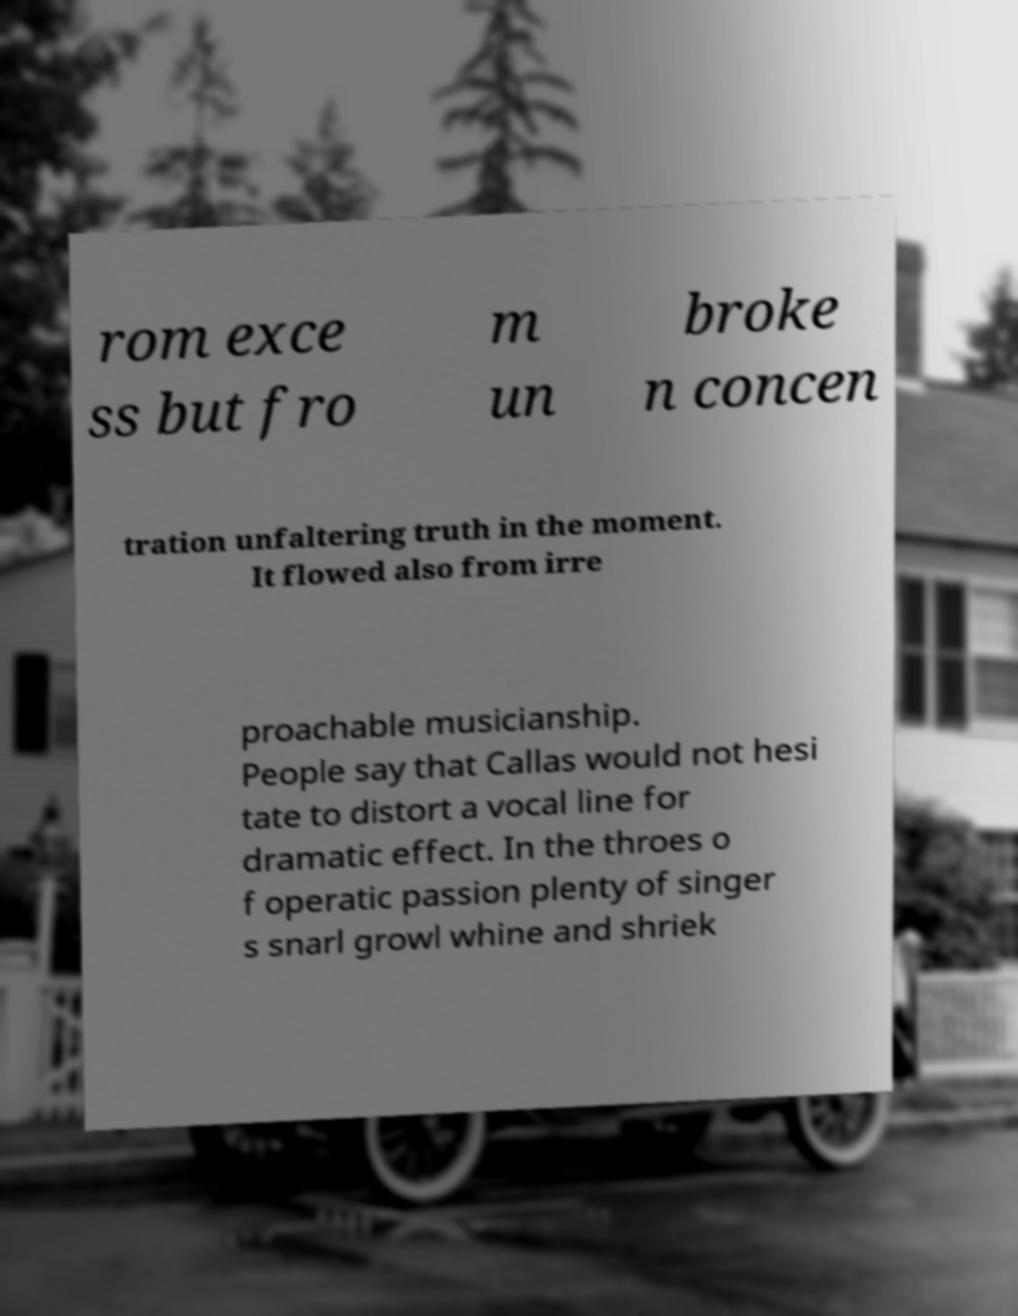What messages or text are displayed in this image? I need them in a readable, typed format. rom exce ss but fro m un broke n concen tration unfaltering truth in the moment. It flowed also from irre proachable musicianship. People say that Callas would not hesi tate to distort a vocal line for dramatic effect. In the throes o f operatic passion plenty of singer s snarl growl whine and shriek 